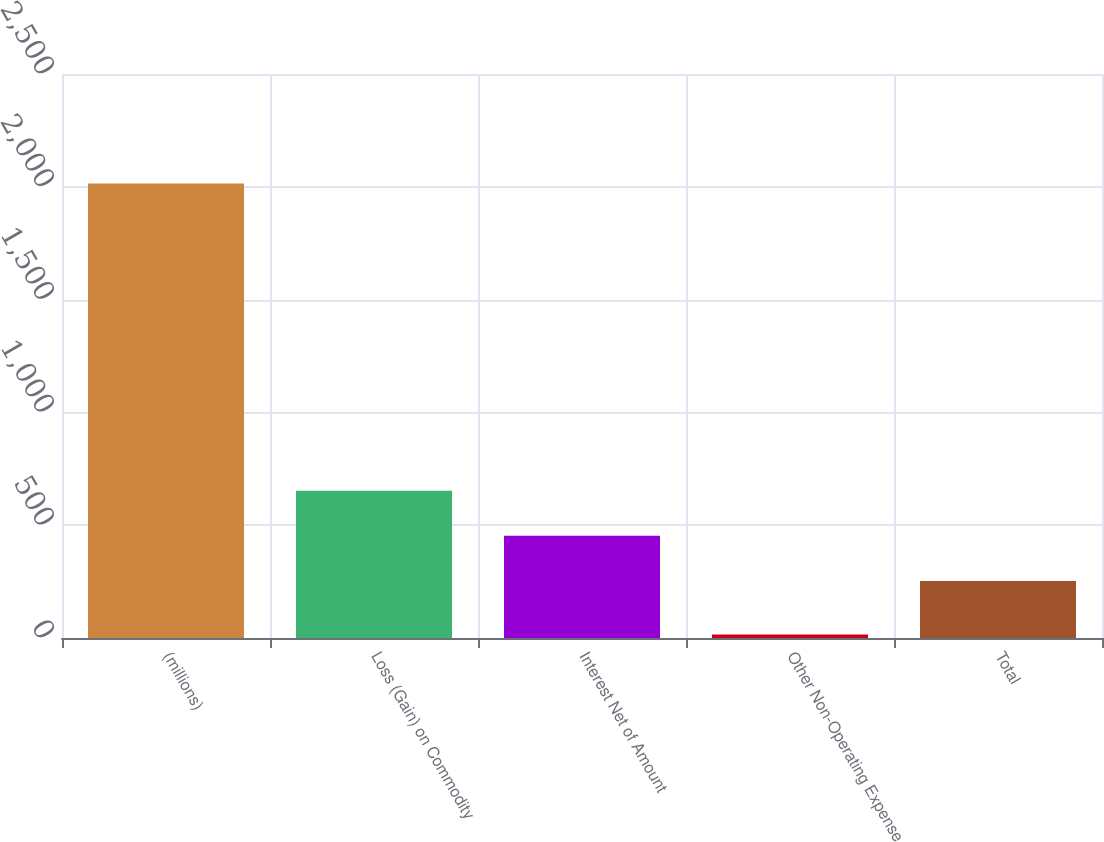Convert chart. <chart><loc_0><loc_0><loc_500><loc_500><bar_chart><fcel>(millions)<fcel>Loss (Gain) on Commodity<fcel>Interest Net of Amount<fcel>Other Non-Operating Expense<fcel>Total<nl><fcel>2015<fcel>653<fcel>453<fcel>15<fcel>253<nl></chart> 